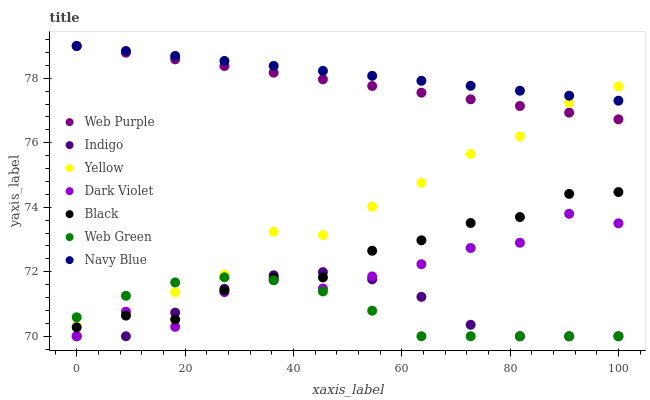Does Web Green have the minimum area under the curve?
Answer yes or no. Yes. Does Navy Blue have the maximum area under the curve?
Answer yes or no. Yes. Does Navy Blue have the minimum area under the curve?
Answer yes or no. No. Does Web Green have the maximum area under the curve?
Answer yes or no. No. Is Web Purple the smoothest?
Answer yes or no. Yes. Is Dark Violet the roughest?
Answer yes or no. Yes. Is Navy Blue the smoothest?
Answer yes or no. No. Is Navy Blue the roughest?
Answer yes or no. No. Does Indigo have the lowest value?
Answer yes or no. Yes. Does Navy Blue have the lowest value?
Answer yes or no. No. Does Web Purple have the highest value?
Answer yes or no. Yes. Does Web Green have the highest value?
Answer yes or no. No. Is Dark Violet less than Navy Blue?
Answer yes or no. Yes. Is Yellow greater than Indigo?
Answer yes or no. Yes. Does Indigo intersect Web Green?
Answer yes or no. Yes. Is Indigo less than Web Green?
Answer yes or no. No. Is Indigo greater than Web Green?
Answer yes or no. No. Does Dark Violet intersect Navy Blue?
Answer yes or no. No. 